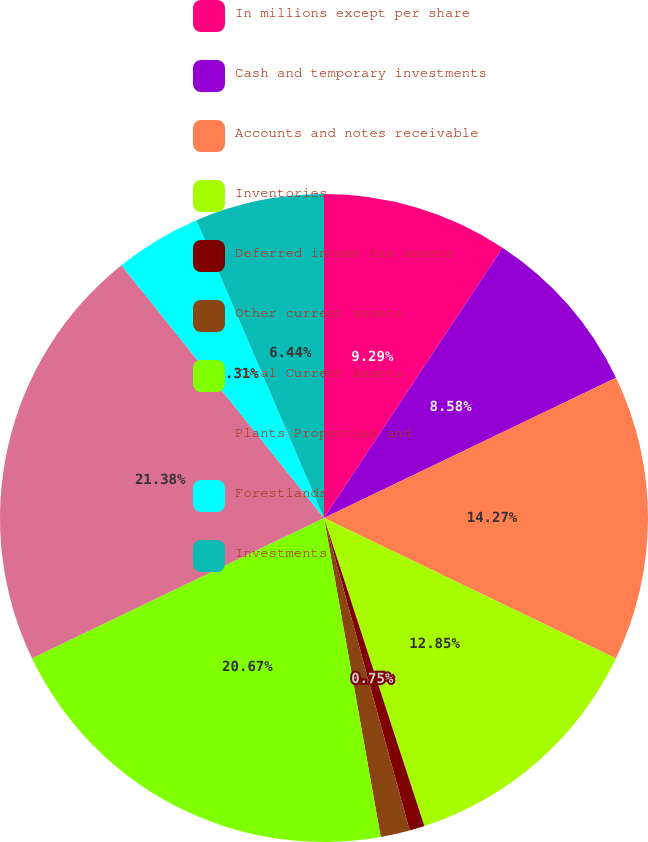Convert chart to OTSL. <chart><loc_0><loc_0><loc_500><loc_500><pie_chart><fcel>In millions except per share<fcel>Cash and temporary investments<fcel>Accounts and notes receivable<fcel>Inventories<fcel>Deferred income tax assets<fcel>Other current assets<fcel>Total Current Assets<fcel>Plants Properties and<fcel>Forestlands<fcel>Investments<nl><fcel>9.29%<fcel>8.58%<fcel>14.27%<fcel>12.85%<fcel>0.75%<fcel>1.46%<fcel>20.67%<fcel>21.38%<fcel>4.31%<fcel>6.44%<nl></chart> 